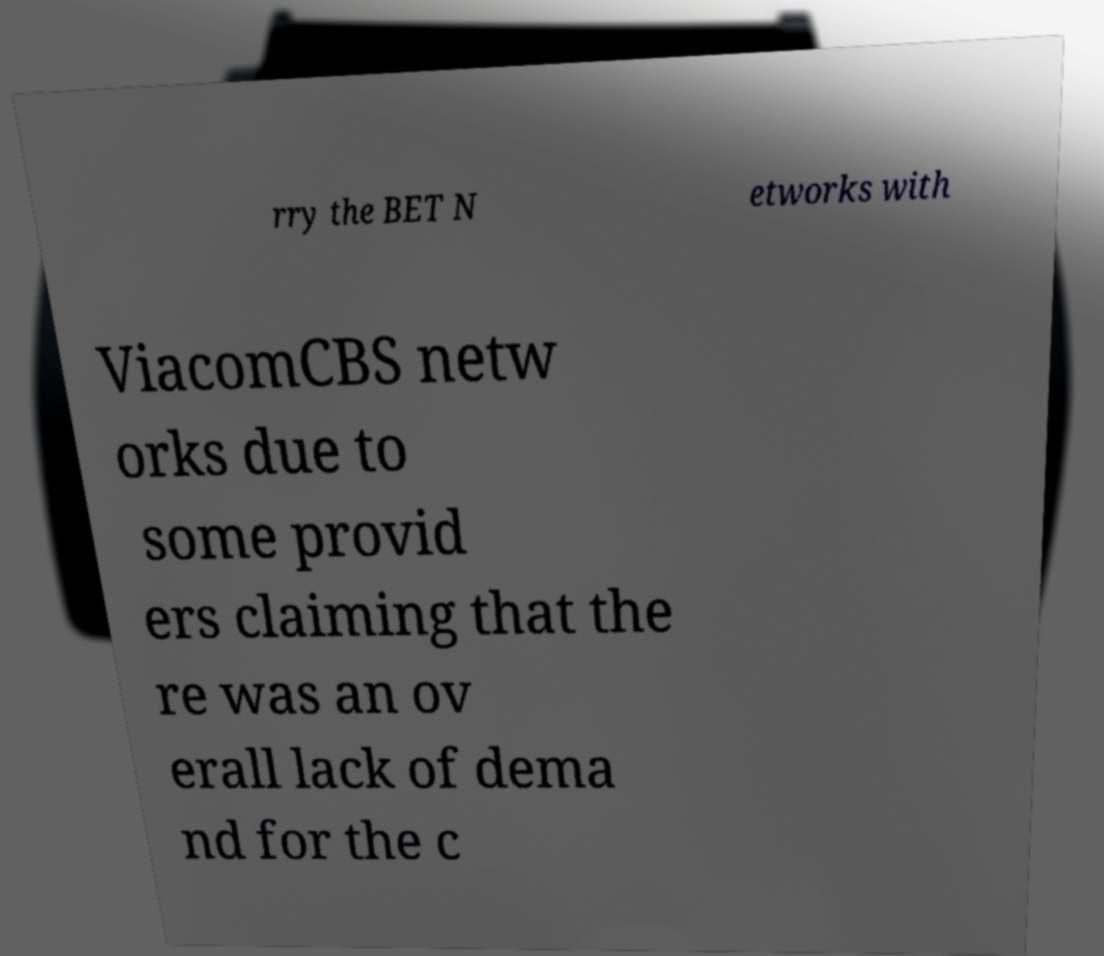There's text embedded in this image that I need extracted. Can you transcribe it verbatim? rry the BET N etworks with ViacomCBS netw orks due to some provid ers claiming that the re was an ov erall lack of dema nd for the c 